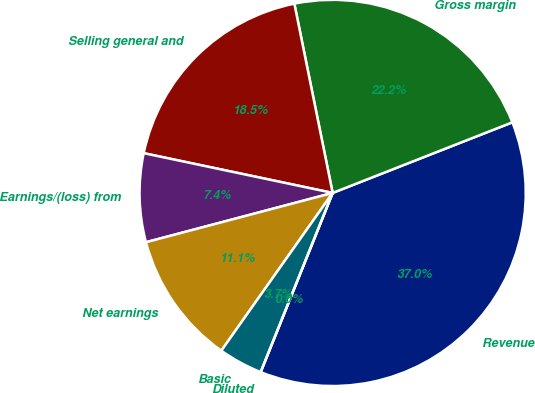Convert chart. <chart><loc_0><loc_0><loc_500><loc_500><pie_chart><fcel>Revenue<fcel>Gross margin<fcel>Selling general and<fcel>Earnings/(loss) from<fcel>Net earnings<fcel>Basic<fcel>Diluted<nl><fcel>37.04%<fcel>22.22%<fcel>18.52%<fcel>7.41%<fcel>11.11%<fcel>3.7%<fcel>0.0%<nl></chart> 